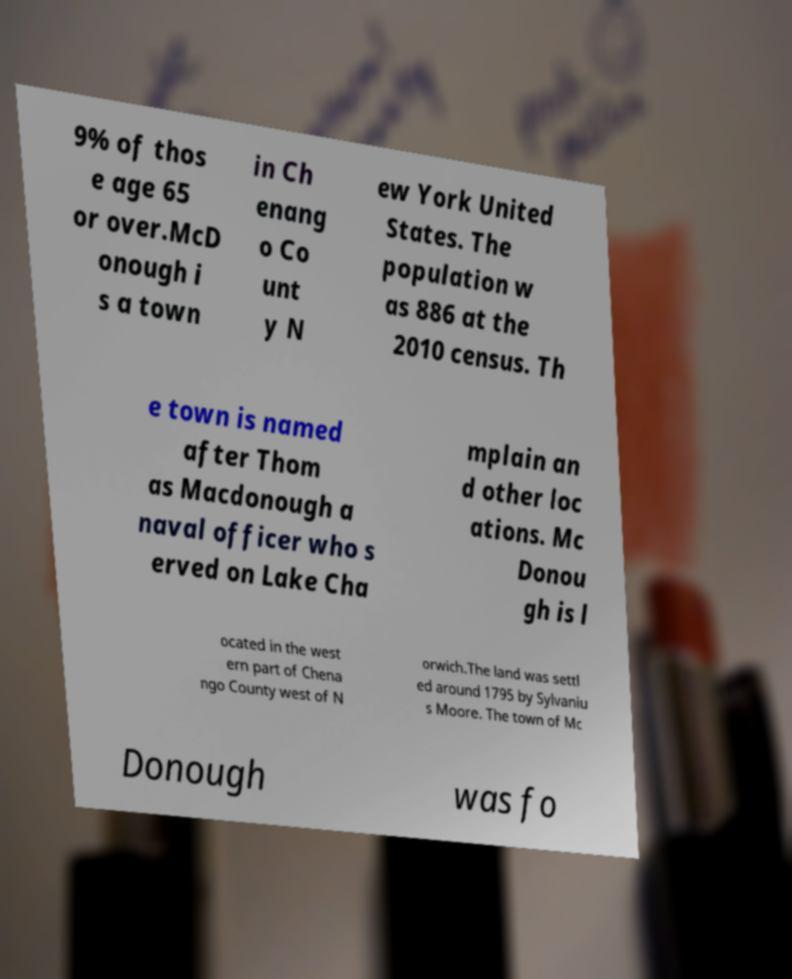Please read and relay the text visible in this image. What does it say? 9% of thos e age 65 or over.McD onough i s a town in Ch enang o Co unt y N ew York United States. The population w as 886 at the 2010 census. Th e town is named after Thom as Macdonough a naval officer who s erved on Lake Cha mplain an d other loc ations. Mc Donou gh is l ocated in the west ern part of Chena ngo County west of N orwich.The land was settl ed around 1795 by Sylvaniu s Moore. The town of Mc Donough was fo 